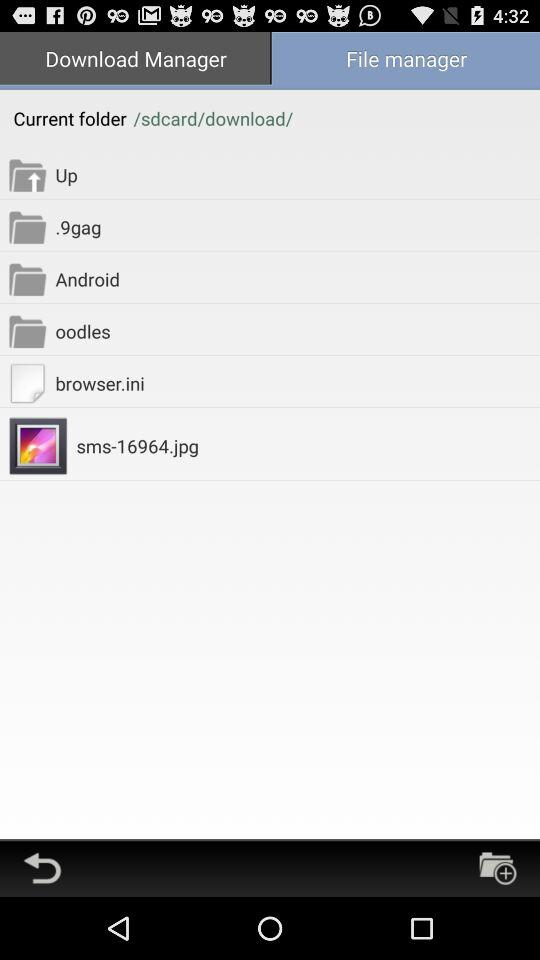Which tab is selected, "Download Manager" or "File manager"? The tab that is selected is "File manager". 